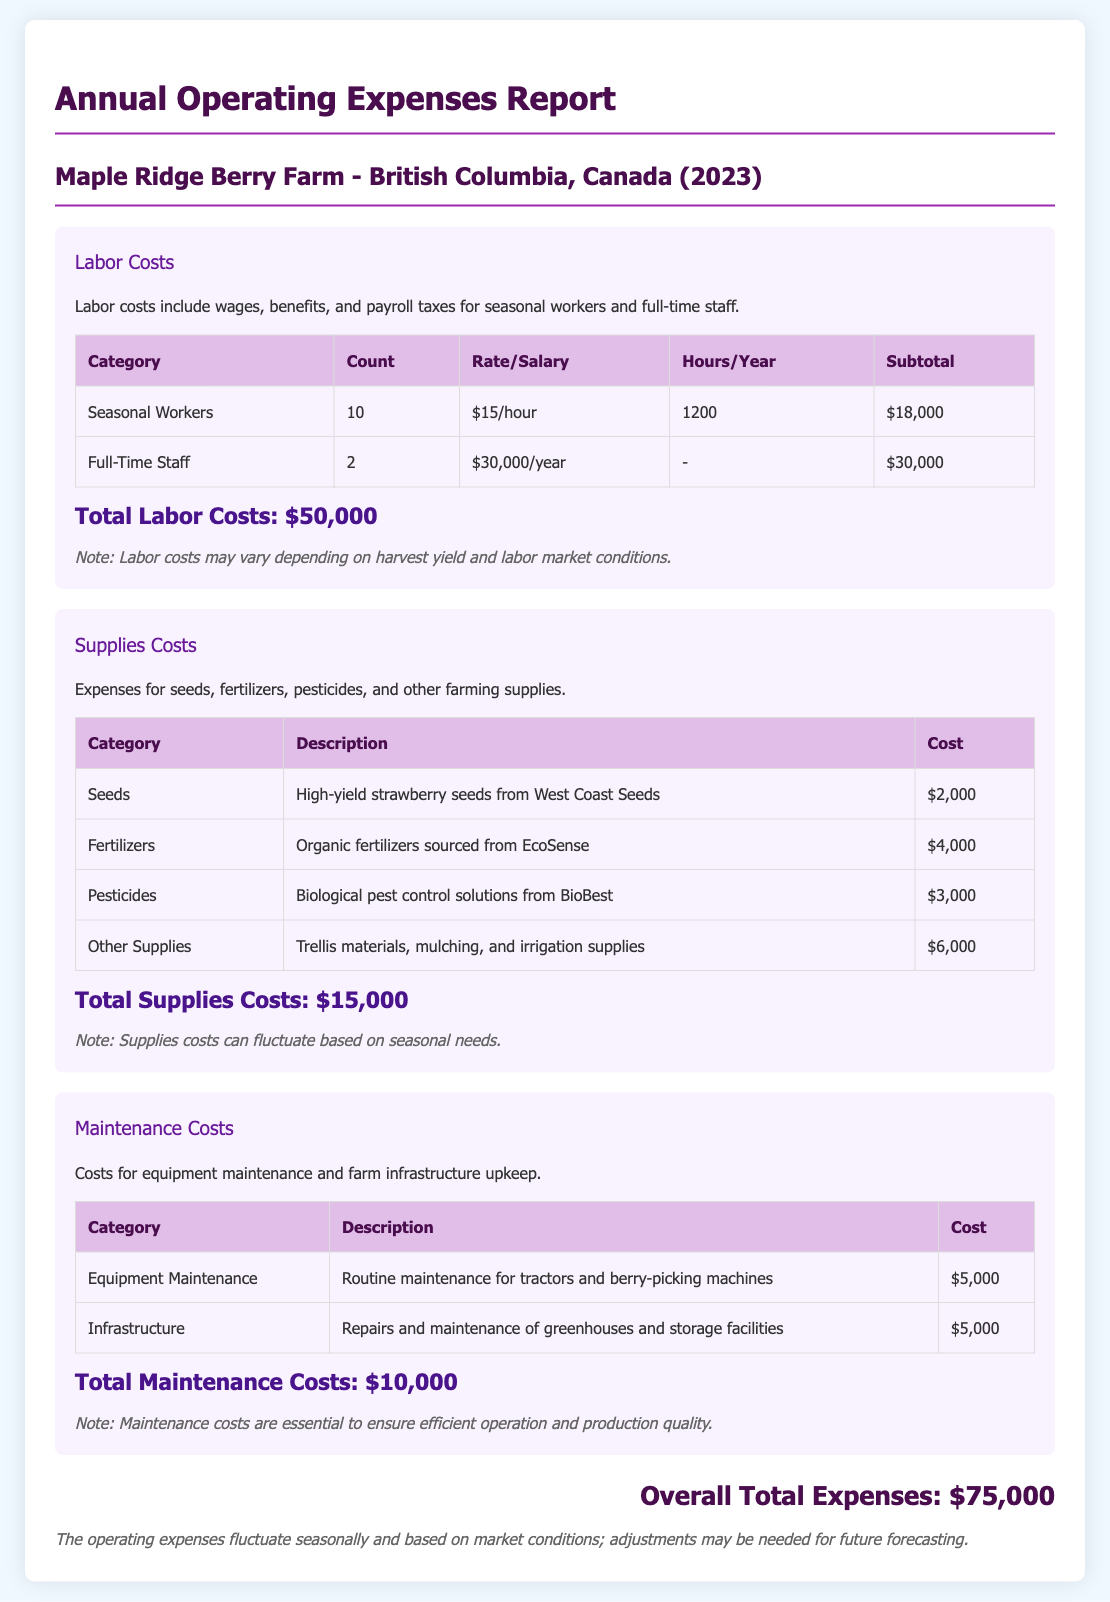What are the total labor costs? The total labor costs are listed at the bottom of the Labor Costs section, which is $50,000.
Answer: $50,000 How many seasonal workers are employed? The document states that there are 10 seasonal workers employed at the farm.
Answer: 10 What is the cost of pesticides? The cost of pesticides is detailed in the Supplies Costs section, which is $3,000.
Answer: $3,000 What are the total supplies costs? The total supplies costs can be found at the end of the Supplies Costs section and is $15,000.
Answer: $15,000 What is the cost for equipment maintenance? The document specifies that the cost for equipment maintenance is $5,000.
Answer: $5,000 How many full-time staff are listed? The report mentions 2 full-time staff members in the Labor Costs section.
Answer: 2 What is the overall total of expenses? The overall total expenses are summarized at the bottom of the report as $75,000.
Answer: $75,000 What type of report is this document? The document is an Annual Operating Expenses Report, specific to the Maple Ridge Berry Farm.
Answer: Annual Operating Expenses Report What is the cost of organic fertilizers? The cost of organic fertilizers is mentioned in the Supplies Costs section, which is $4,000.
Answer: $4,000 